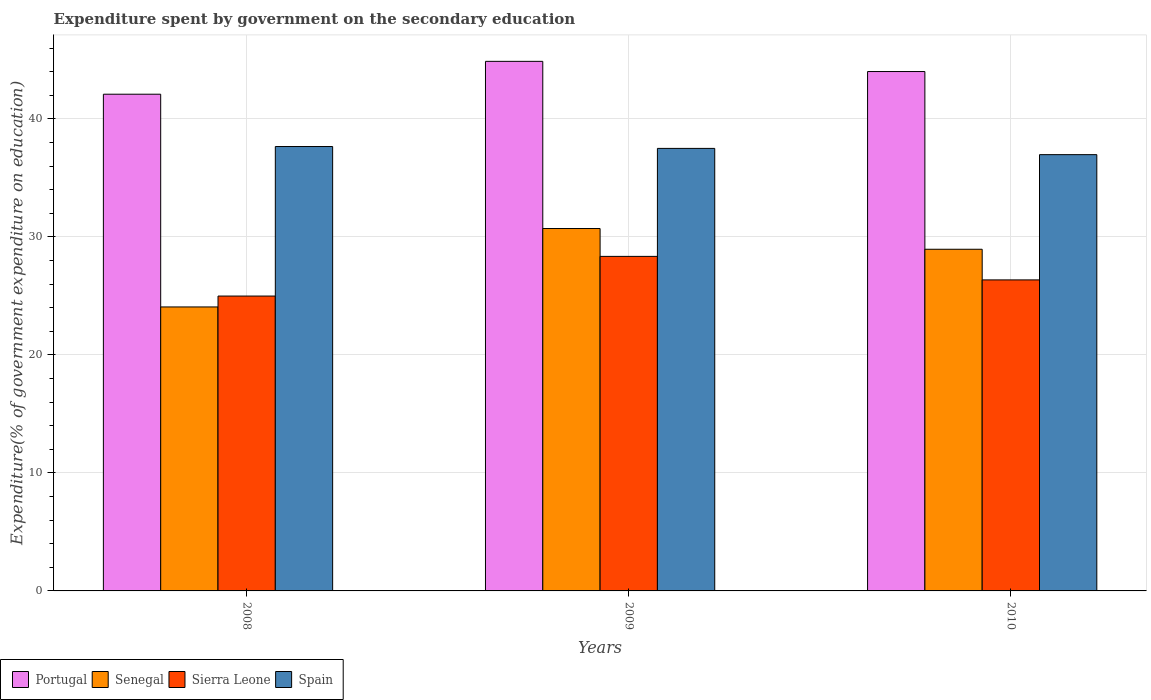How many different coloured bars are there?
Your answer should be very brief. 4. Are the number of bars per tick equal to the number of legend labels?
Provide a short and direct response. Yes. How many bars are there on the 2nd tick from the right?
Provide a short and direct response. 4. What is the label of the 2nd group of bars from the left?
Your response must be concise. 2009. What is the expenditure spent by government on the secondary education in Sierra Leone in 2010?
Your answer should be compact. 26.36. Across all years, what is the maximum expenditure spent by government on the secondary education in Sierra Leone?
Offer a very short reply. 28.35. Across all years, what is the minimum expenditure spent by government on the secondary education in Sierra Leone?
Provide a succinct answer. 24.99. In which year was the expenditure spent by government on the secondary education in Sierra Leone minimum?
Ensure brevity in your answer.  2008. What is the total expenditure spent by government on the secondary education in Sierra Leone in the graph?
Ensure brevity in your answer.  79.69. What is the difference between the expenditure spent by government on the secondary education in Portugal in 2008 and that in 2009?
Provide a succinct answer. -2.78. What is the difference between the expenditure spent by government on the secondary education in Sierra Leone in 2008 and the expenditure spent by government on the secondary education in Senegal in 2009?
Make the answer very short. -5.72. What is the average expenditure spent by government on the secondary education in Spain per year?
Provide a succinct answer. 37.38. In the year 2010, what is the difference between the expenditure spent by government on the secondary education in Portugal and expenditure spent by government on the secondary education in Sierra Leone?
Your answer should be compact. 17.66. In how many years, is the expenditure spent by government on the secondary education in Spain greater than 44 %?
Provide a succinct answer. 0. What is the ratio of the expenditure spent by government on the secondary education in Portugal in 2008 to that in 2009?
Offer a very short reply. 0.94. Is the difference between the expenditure spent by government on the secondary education in Portugal in 2008 and 2010 greater than the difference between the expenditure spent by government on the secondary education in Sierra Leone in 2008 and 2010?
Offer a very short reply. No. What is the difference between the highest and the second highest expenditure spent by government on the secondary education in Sierra Leone?
Give a very brief answer. 1.99. What is the difference between the highest and the lowest expenditure spent by government on the secondary education in Portugal?
Give a very brief answer. 2.78. Is the sum of the expenditure spent by government on the secondary education in Senegal in 2009 and 2010 greater than the maximum expenditure spent by government on the secondary education in Spain across all years?
Keep it short and to the point. Yes. What does the 2nd bar from the left in 2009 represents?
Provide a succinct answer. Senegal. What does the 4th bar from the right in 2009 represents?
Ensure brevity in your answer.  Portugal. Is it the case that in every year, the sum of the expenditure spent by government on the secondary education in Senegal and expenditure spent by government on the secondary education in Spain is greater than the expenditure spent by government on the secondary education in Portugal?
Ensure brevity in your answer.  Yes. Are all the bars in the graph horizontal?
Offer a terse response. No. Are the values on the major ticks of Y-axis written in scientific E-notation?
Your answer should be very brief. No. Where does the legend appear in the graph?
Make the answer very short. Bottom left. What is the title of the graph?
Your response must be concise. Expenditure spent by government on the secondary education. What is the label or title of the Y-axis?
Ensure brevity in your answer.  Expenditure(% of government expenditure on education). What is the Expenditure(% of government expenditure on education) of Portugal in 2008?
Your answer should be very brief. 42.09. What is the Expenditure(% of government expenditure on education) of Senegal in 2008?
Provide a short and direct response. 24.06. What is the Expenditure(% of government expenditure on education) in Sierra Leone in 2008?
Offer a very short reply. 24.99. What is the Expenditure(% of government expenditure on education) of Spain in 2008?
Make the answer very short. 37.66. What is the Expenditure(% of government expenditure on education) of Portugal in 2009?
Keep it short and to the point. 44.88. What is the Expenditure(% of government expenditure on education) in Senegal in 2009?
Provide a succinct answer. 30.71. What is the Expenditure(% of government expenditure on education) of Sierra Leone in 2009?
Your response must be concise. 28.35. What is the Expenditure(% of government expenditure on education) in Spain in 2009?
Your answer should be very brief. 37.5. What is the Expenditure(% of government expenditure on education) of Portugal in 2010?
Give a very brief answer. 44.01. What is the Expenditure(% of government expenditure on education) in Senegal in 2010?
Make the answer very short. 28.95. What is the Expenditure(% of government expenditure on education) in Sierra Leone in 2010?
Offer a very short reply. 26.36. What is the Expenditure(% of government expenditure on education) in Spain in 2010?
Ensure brevity in your answer.  36.97. Across all years, what is the maximum Expenditure(% of government expenditure on education) in Portugal?
Provide a succinct answer. 44.88. Across all years, what is the maximum Expenditure(% of government expenditure on education) of Senegal?
Make the answer very short. 30.71. Across all years, what is the maximum Expenditure(% of government expenditure on education) of Sierra Leone?
Your response must be concise. 28.35. Across all years, what is the maximum Expenditure(% of government expenditure on education) of Spain?
Provide a succinct answer. 37.66. Across all years, what is the minimum Expenditure(% of government expenditure on education) in Portugal?
Offer a terse response. 42.09. Across all years, what is the minimum Expenditure(% of government expenditure on education) in Senegal?
Provide a short and direct response. 24.06. Across all years, what is the minimum Expenditure(% of government expenditure on education) of Sierra Leone?
Give a very brief answer. 24.99. Across all years, what is the minimum Expenditure(% of government expenditure on education) of Spain?
Your answer should be very brief. 36.97. What is the total Expenditure(% of government expenditure on education) in Portugal in the graph?
Ensure brevity in your answer.  130.98. What is the total Expenditure(% of government expenditure on education) in Senegal in the graph?
Your response must be concise. 83.73. What is the total Expenditure(% of government expenditure on education) in Sierra Leone in the graph?
Offer a terse response. 79.69. What is the total Expenditure(% of government expenditure on education) of Spain in the graph?
Your answer should be compact. 112.13. What is the difference between the Expenditure(% of government expenditure on education) of Portugal in 2008 and that in 2009?
Your answer should be compact. -2.78. What is the difference between the Expenditure(% of government expenditure on education) in Senegal in 2008 and that in 2009?
Offer a very short reply. -6.65. What is the difference between the Expenditure(% of government expenditure on education) in Sierra Leone in 2008 and that in 2009?
Your response must be concise. -3.36. What is the difference between the Expenditure(% of government expenditure on education) of Spain in 2008 and that in 2009?
Make the answer very short. 0.16. What is the difference between the Expenditure(% of government expenditure on education) in Portugal in 2008 and that in 2010?
Offer a terse response. -1.92. What is the difference between the Expenditure(% of government expenditure on education) in Senegal in 2008 and that in 2010?
Provide a succinct answer. -4.89. What is the difference between the Expenditure(% of government expenditure on education) of Sierra Leone in 2008 and that in 2010?
Provide a succinct answer. -1.37. What is the difference between the Expenditure(% of government expenditure on education) of Spain in 2008 and that in 2010?
Make the answer very short. 0.69. What is the difference between the Expenditure(% of government expenditure on education) of Portugal in 2009 and that in 2010?
Offer a terse response. 0.86. What is the difference between the Expenditure(% of government expenditure on education) in Senegal in 2009 and that in 2010?
Provide a short and direct response. 1.76. What is the difference between the Expenditure(% of government expenditure on education) of Sierra Leone in 2009 and that in 2010?
Your answer should be very brief. 1.99. What is the difference between the Expenditure(% of government expenditure on education) of Spain in 2009 and that in 2010?
Provide a succinct answer. 0.53. What is the difference between the Expenditure(% of government expenditure on education) of Portugal in 2008 and the Expenditure(% of government expenditure on education) of Senegal in 2009?
Provide a succinct answer. 11.38. What is the difference between the Expenditure(% of government expenditure on education) in Portugal in 2008 and the Expenditure(% of government expenditure on education) in Sierra Leone in 2009?
Your answer should be very brief. 13.74. What is the difference between the Expenditure(% of government expenditure on education) of Portugal in 2008 and the Expenditure(% of government expenditure on education) of Spain in 2009?
Give a very brief answer. 4.59. What is the difference between the Expenditure(% of government expenditure on education) in Senegal in 2008 and the Expenditure(% of government expenditure on education) in Sierra Leone in 2009?
Your answer should be compact. -4.29. What is the difference between the Expenditure(% of government expenditure on education) of Senegal in 2008 and the Expenditure(% of government expenditure on education) of Spain in 2009?
Offer a terse response. -13.44. What is the difference between the Expenditure(% of government expenditure on education) of Sierra Leone in 2008 and the Expenditure(% of government expenditure on education) of Spain in 2009?
Your answer should be very brief. -12.51. What is the difference between the Expenditure(% of government expenditure on education) of Portugal in 2008 and the Expenditure(% of government expenditure on education) of Senegal in 2010?
Your answer should be very brief. 13.14. What is the difference between the Expenditure(% of government expenditure on education) of Portugal in 2008 and the Expenditure(% of government expenditure on education) of Sierra Leone in 2010?
Offer a very short reply. 15.74. What is the difference between the Expenditure(% of government expenditure on education) of Portugal in 2008 and the Expenditure(% of government expenditure on education) of Spain in 2010?
Provide a succinct answer. 5.12. What is the difference between the Expenditure(% of government expenditure on education) in Senegal in 2008 and the Expenditure(% of government expenditure on education) in Sierra Leone in 2010?
Give a very brief answer. -2.29. What is the difference between the Expenditure(% of government expenditure on education) in Senegal in 2008 and the Expenditure(% of government expenditure on education) in Spain in 2010?
Keep it short and to the point. -12.91. What is the difference between the Expenditure(% of government expenditure on education) in Sierra Leone in 2008 and the Expenditure(% of government expenditure on education) in Spain in 2010?
Provide a short and direct response. -11.98. What is the difference between the Expenditure(% of government expenditure on education) in Portugal in 2009 and the Expenditure(% of government expenditure on education) in Senegal in 2010?
Provide a succinct answer. 15.92. What is the difference between the Expenditure(% of government expenditure on education) in Portugal in 2009 and the Expenditure(% of government expenditure on education) in Sierra Leone in 2010?
Keep it short and to the point. 18.52. What is the difference between the Expenditure(% of government expenditure on education) of Portugal in 2009 and the Expenditure(% of government expenditure on education) of Spain in 2010?
Offer a terse response. 7.91. What is the difference between the Expenditure(% of government expenditure on education) of Senegal in 2009 and the Expenditure(% of government expenditure on education) of Sierra Leone in 2010?
Provide a succinct answer. 4.35. What is the difference between the Expenditure(% of government expenditure on education) in Senegal in 2009 and the Expenditure(% of government expenditure on education) in Spain in 2010?
Ensure brevity in your answer.  -6.26. What is the difference between the Expenditure(% of government expenditure on education) of Sierra Leone in 2009 and the Expenditure(% of government expenditure on education) of Spain in 2010?
Keep it short and to the point. -8.62. What is the average Expenditure(% of government expenditure on education) of Portugal per year?
Your answer should be very brief. 43.66. What is the average Expenditure(% of government expenditure on education) of Senegal per year?
Your answer should be very brief. 27.91. What is the average Expenditure(% of government expenditure on education) in Sierra Leone per year?
Provide a succinct answer. 26.56. What is the average Expenditure(% of government expenditure on education) in Spain per year?
Ensure brevity in your answer.  37.38. In the year 2008, what is the difference between the Expenditure(% of government expenditure on education) of Portugal and Expenditure(% of government expenditure on education) of Senegal?
Your response must be concise. 18.03. In the year 2008, what is the difference between the Expenditure(% of government expenditure on education) in Portugal and Expenditure(% of government expenditure on education) in Sierra Leone?
Make the answer very short. 17.11. In the year 2008, what is the difference between the Expenditure(% of government expenditure on education) in Portugal and Expenditure(% of government expenditure on education) in Spain?
Your answer should be very brief. 4.43. In the year 2008, what is the difference between the Expenditure(% of government expenditure on education) in Senegal and Expenditure(% of government expenditure on education) in Sierra Leone?
Give a very brief answer. -0.92. In the year 2008, what is the difference between the Expenditure(% of government expenditure on education) in Senegal and Expenditure(% of government expenditure on education) in Spain?
Your answer should be compact. -13.59. In the year 2008, what is the difference between the Expenditure(% of government expenditure on education) in Sierra Leone and Expenditure(% of government expenditure on education) in Spain?
Provide a short and direct response. -12.67. In the year 2009, what is the difference between the Expenditure(% of government expenditure on education) in Portugal and Expenditure(% of government expenditure on education) in Senegal?
Your response must be concise. 14.17. In the year 2009, what is the difference between the Expenditure(% of government expenditure on education) of Portugal and Expenditure(% of government expenditure on education) of Sierra Leone?
Ensure brevity in your answer.  16.53. In the year 2009, what is the difference between the Expenditure(% of government expenditure on education) in Portugal and Expenditure(% of government expenditure on education) in Spain?
Give a very brief answer. 7.38. In the year 2009, what is the difference between the Expenditure(% of government expenditure on education) of Senegal and Expenditure(% of government expenditure on education) of Sierra Leone?
Provide a short and direct response. 2.36. In the year 2009, what is the difference between the Expenditure(% of government expenditure on education) of Senegal and Expenditure(% of government expenditure on education) of Spain?
Provide a succinct answer. -6.79. In the year 2009, what is the difference between the Expenditure(% of government expenditure on education) of Sierra Leone and Expenditure(% of government expenditure on education) of Spain?
Your response must be concise. -9.15. In the year 2010, what is the difference between the Expenditure(% of government expenditure on education) of Portugal and Expenditure(% of government expenditure on education) of Senegal?
Ensure brevity in your answer.  15.06. In the year 2010, what is the difference between the Expenditure(% of government expenditure on education) of Portugal and Expenditure(% of government expenditure on education) of Sierra Leone?
Make the answer very short. 17.66. In the year 2010, what is the difference between the Expenditure(% of government expenditure on education) in Portugal and Expenditure(% of government expenditure on education) in Spain?
Offer a terse response. 7.04. In the year 2010, what is the difference between the Expenditure(% of government expenditure on education) of Senegal and Expenditure(% of government expenditure on education) of Sierra Leone?
Offer a terse response. 2.6. In the year 2010, what is the difference between the Expenditure(% of government expenditure on education) of Senegal and Expenditure(% of government expenditure on education) of Spain?
Your answer should be compact. -8.02. In the year 2010, what is the difference between the Expenditure(% of government expenditure on education) of Sierra Leone and Expenditure(% of government expenditure on education) of Spain?
Provide a short and direct response. -10.61. What is the ratio of the Expenditure(% of government expenditure on education) of Portugal in 2008 to that in 2009?
Offer a terse response. 0.94. What is the ratio of the Expenditure(% of government expenditure on education) of Senegal in 2008 to that in 2009?
Keep it short and to the point. 0.78. What is the ratio of the Expenditure(% of government expenditure on education) in Sierra Leone in 2008 to that in 2009?
Your answer should be very brief. 0.88. What is the ratio of the Expenditure(% of government expenditure on education) of Spain in 2008 to that in 2009?
Give a very brief answer. 1. What is the ratio of the Expenditure(% of government expenditure on education) in Portugal in 2008 to that in 2010?
Make the answer very short. 0.96. What is the ratio of the Expenditure(% of government expenditure on education) of Senegal in 2008 to that in 2010?
Offer a terse response. 0.83. What is the ratio of the Expenditure(% of government expenditure on education) of Sierra Leone in 2008 to that in 2010?
Your answer should be compact. 0.95. What is the ratio of the Expenditure(% of government expenditure on education) in Spain in 2008 to that in 2010?
Your response must be concise. 1.02. What is the ratio of the Expenditure(% of government expenditure on education) of Portugal in 2009 to that in 2010?
Your answer should be very brief. 1.02. What is the ratio of the Expenditure(% of government expenditure on education) in Senegal in 2009 to that in 2010?
Ensure brevity in your answer.  1.06. What is the ratio of the Expenditure(% of government expenditure on education) of Sierra Leone in 2009 to that in 2010?
Your answer should be compact. 1.08. What is the ratio of the Expenditure(% of government expenditure on education) in Spain in 2009 to that in 2010?
Your answer should be very brief. 1.01. What is the difference between the highest and the second highest Expenditure(% of government expenditure on education) of Portugal?
Offer a terse response. 0.86. What is the difference between the highest and the second highest Expenditure(% of government expenditure on education) in Senegal?
Your answer should be compact. 1.76. What is the difference between the highest and the second highest Expenditure(% of government expenditure on education) of Sierra Leone?
Ensure brevity in your answer.  1.99. What is the difference between the highest and the second highest Expenditure(% of government expenditure on education) of Spain?
Your response must be concise. 0.16. What is the difference between the highest and the lowest Expenditure(% of government expenditure on education) of Portugal?
Keep it short and to the point. 2.78. What is the difference between the highest and the lowest Expenditure(% of government expenditure on education) in Senegal?
Your answer should be compact. 6.65. What is the difference between the highest and the lowest Expenditure(% of government expenditure on education) in Sierra Leone?
Keep it short and to the point. 3.36. What is the difference between the highest and the lowest Expenditure(% of government expenditure on education) in Spain?
Make the answer very short. 0.69. 